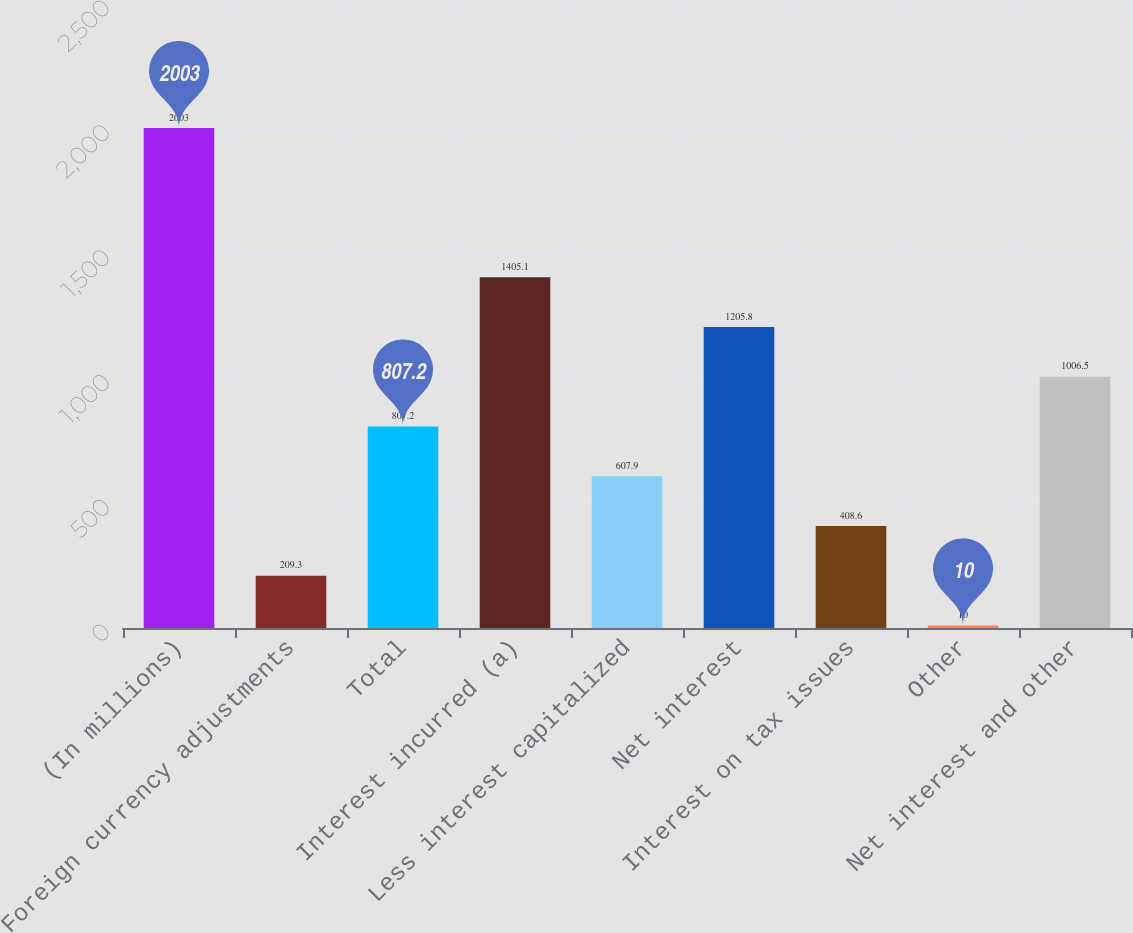Convert chart to OTSL. <chart><loc_0><loc_0><loc_500><loc_500><bar_chart><fcel>(In millions)<fcel>Foreign currency adjustments<fcel>Total<fcel>Interest incurred (a)<fcel>Less interest capitalized<fcel>Net interest<fcel>Interest on tax issues<fcel>Other<fcel>Net interest and other<nl><fcel>2003<fcel>209.3<fcel>807.2<fcel>1405.1<fcel>607.9<fcel>1205.8<fcel>408.6<fcel>10<fcel>1006.5<nl></chart> 